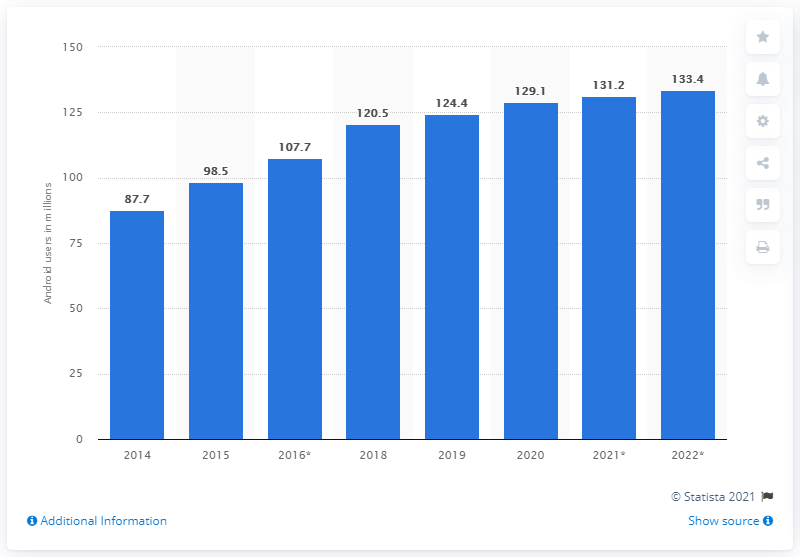Identify some key points in this picture. Based on projections, it is expected that there will be approximately 131.2 million Android smartphone users in the United States by 2021. There were 129.1 million Android smartphone users in the United States in 2020. 